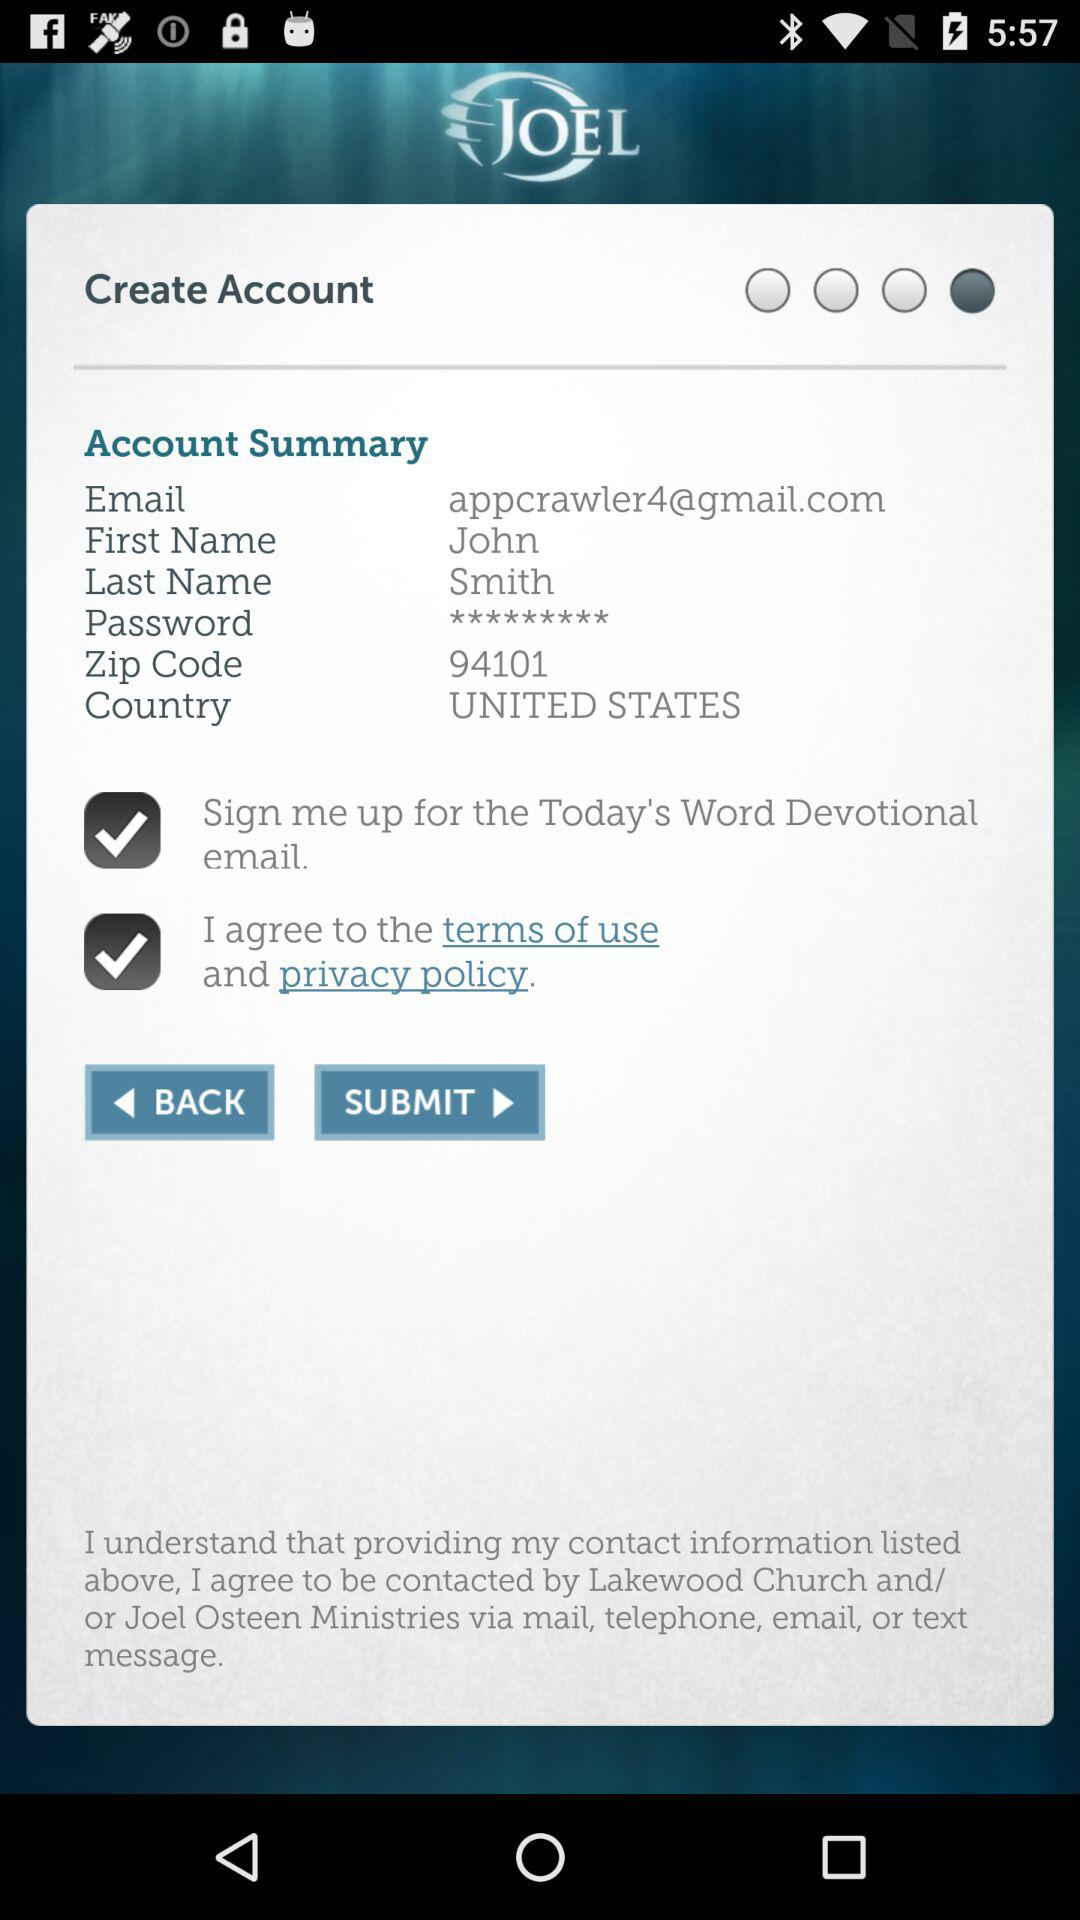What is the selected country? The selected country is the United States. 